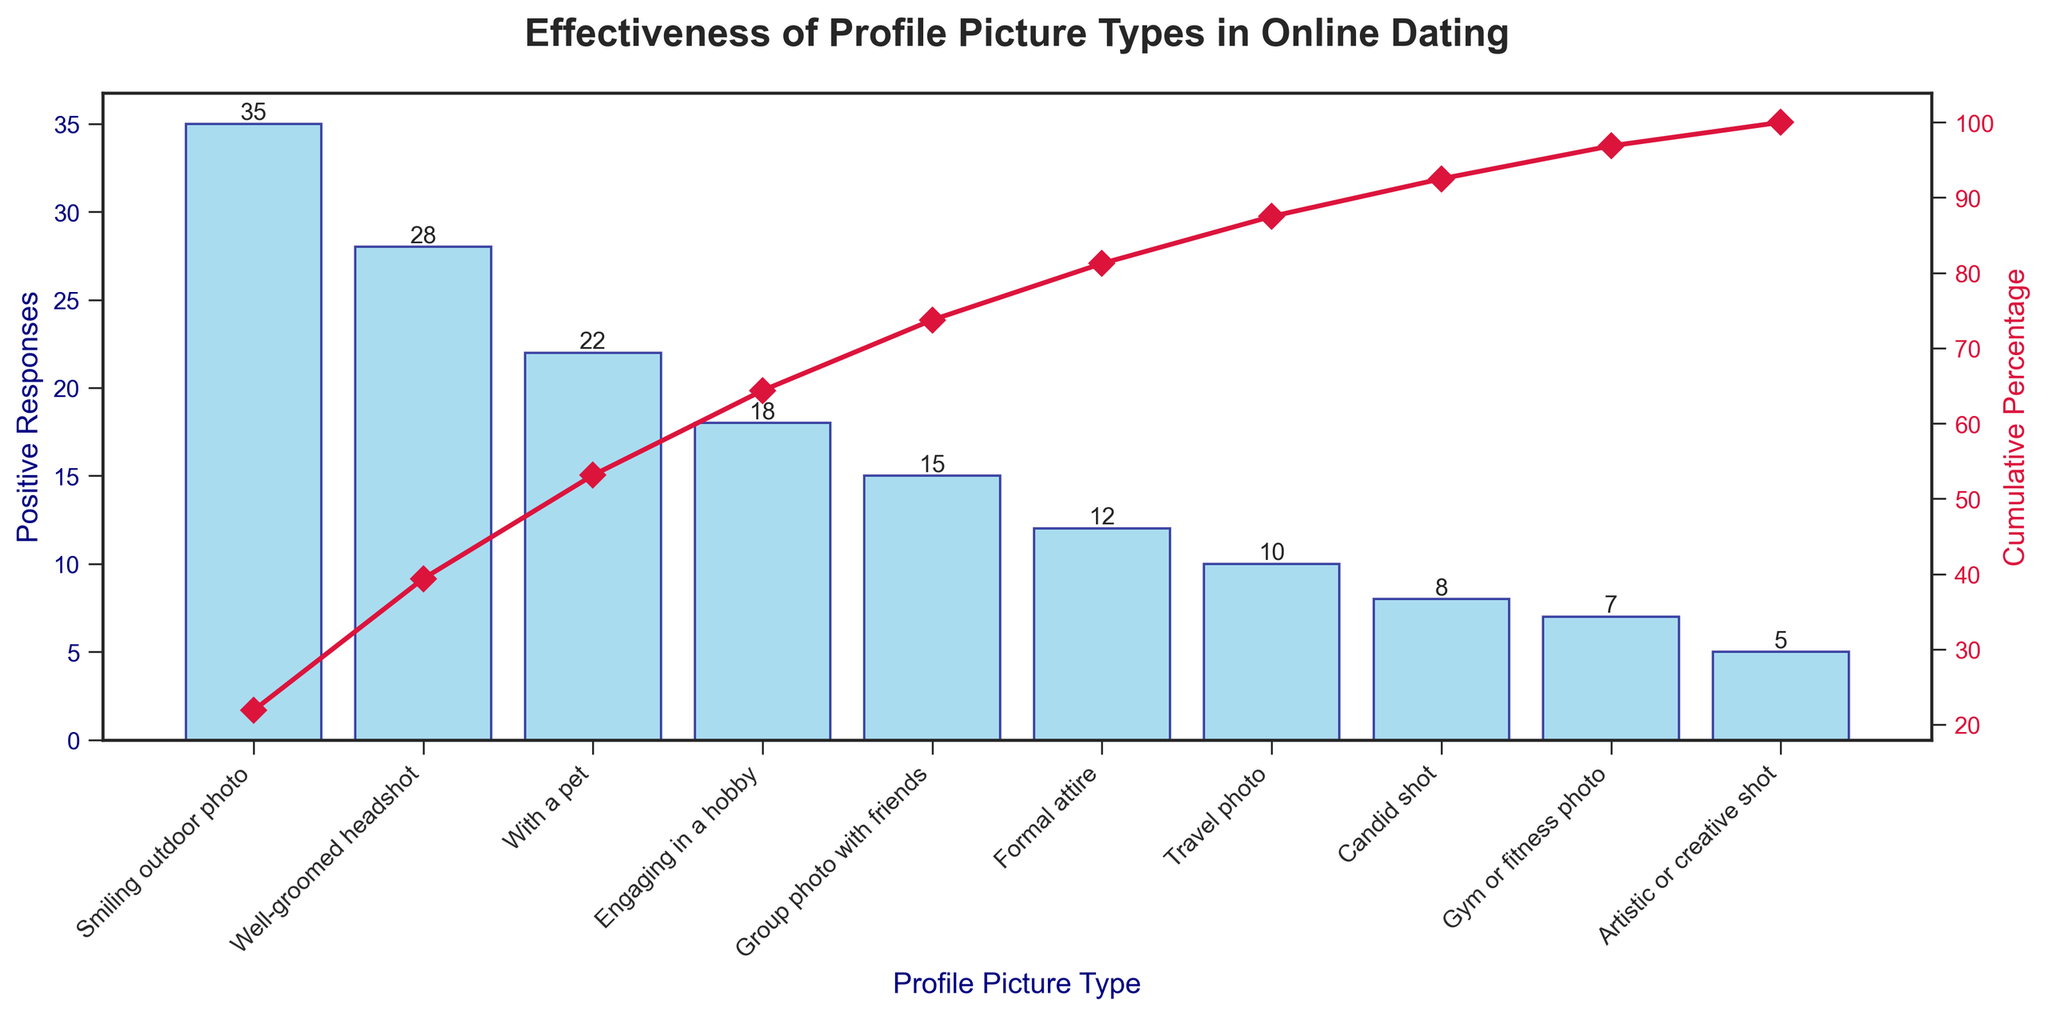What's the title of the chart? The title of the chart is displayed at the top center of the figure.
Answer: Effectiveness of Profile Picture Types in Online Dating How many profile picture types are analyzed in the chart? Count the number of bars on the x-axis, which each represent a profile picture type.
Answer: 10 What is the x-axis label? The x-axis label is displayed at the bottom of the chart, indicating what each bar represents.
Answer: Profile Picture Type Which profile picture type received the highest number of positive responses? Identify the tallest bar on the chart, which represents the profile picture type with the most positive responses.
Answer: Smiling outdoor photo What percentage of the total positive responses is accumulated by the top three profile picture types? Look at the cumulative percentage line and see the cumulative percentage after the third bar (third profile picture type).
Answer: 73% Which profile picture type received fewer positive responses: a candid shot or a gym or fitness photo? Compare the heights of the bars representing the candid shot and gym or fitness photo. The shorter bar represents the one with fewer positive responses.
Answer: Candid shot What is the cumulative percentage after the first five profile picture types? Check the value of the cumulative percentage line after the fifth bar (fifth profile picture type).
Answer: 83% Which is more effective, a formal attire photo or a group photo with friends, in terms of positive responses? Compare the heights of the bars representing formal attire photos and group photos with friends to see which one is taller.
Answer: Group photo with friends What is the cumulative percentage at the last profile picture type? Look at the value of the cumulative percentage line after the last bar (representing the last profile picture type).
Answer: 100% How many more positive responses does a well-groomed headshot receive than a candid shot? Subtract the number of positive responses for a candid shot from the number for a well-groomed headshot.
Answer: 20 